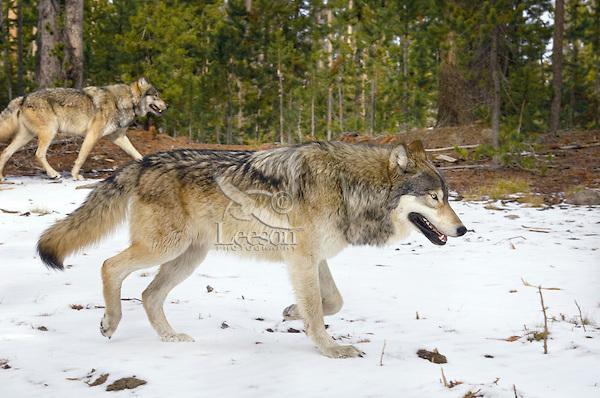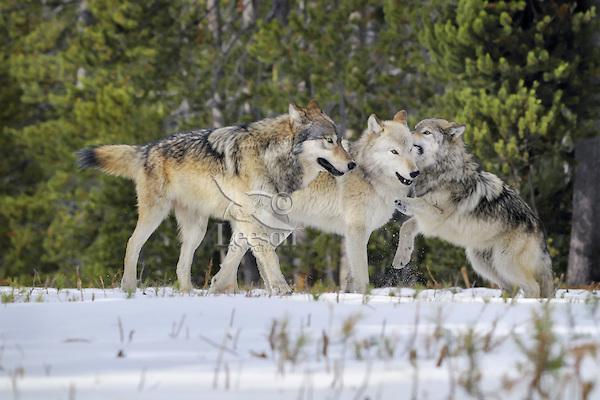The first image is the image on the left, the second image is the image on the right. Examine the images to the left and right. Is the description "The right image contains three wolves in the snow." accurate? Answer yes or no. Yes. The first image is the image on the left, the second image is the image on the right. Considering the images on both sides, is "The animals in the image on the right are in the snow." valid? Answer yes or no. Yes. 